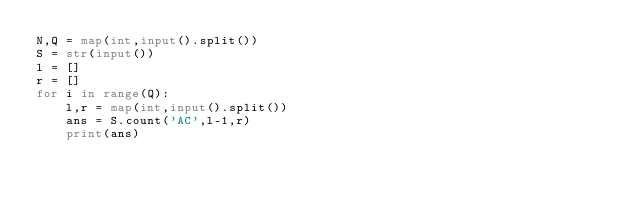Convert code to text. <code><loc_0><loc_0><loc_500><loc_500><_Python_>N,Q = map(int,input().split())
S = str(input())
l = []
r = []
for i in range(Q):
    l,r = map(int,input().split())
    ans = S.count('AC',l-1,r)
    print(ans)
</code> 